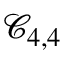Convert formula to latex. <formula><loc_0><loc_0><loc_500><loc_500>\mathcal { C } _ { 4 , 4 }</formula> 